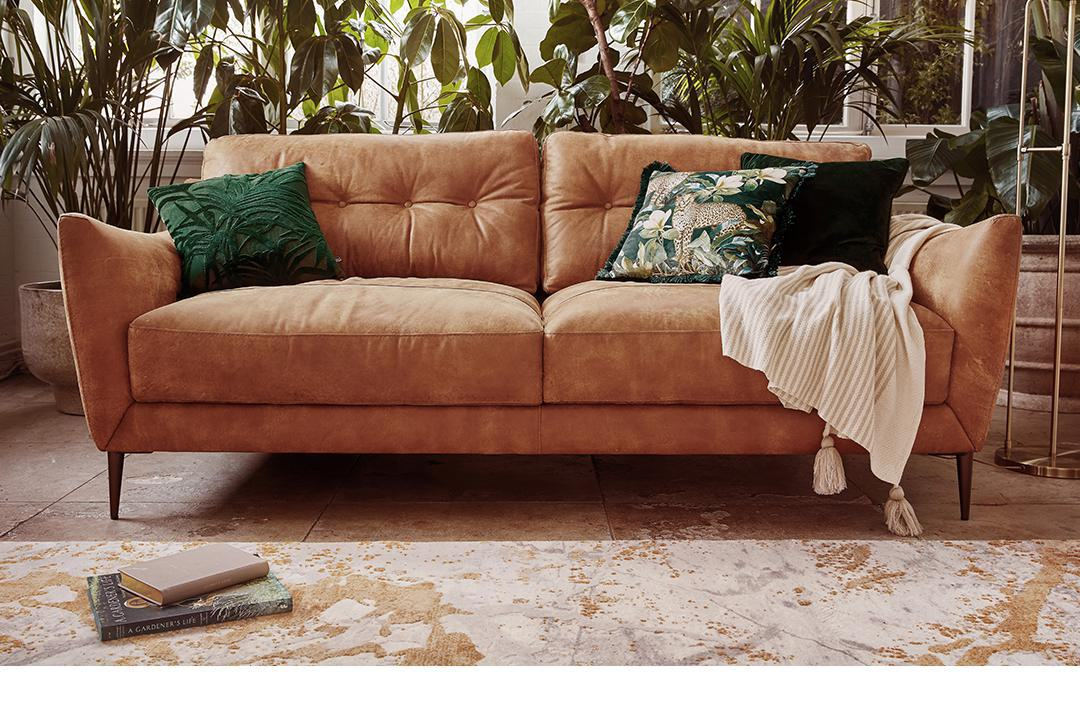What kind of atmosphere does the setting evoke? The setting evokes a tranquil, relaxed atmosphere. The choice of soft furnishings, the presence of greenery, and the muted, earthy color palette all contribute to a sense of comfort and serenity. 